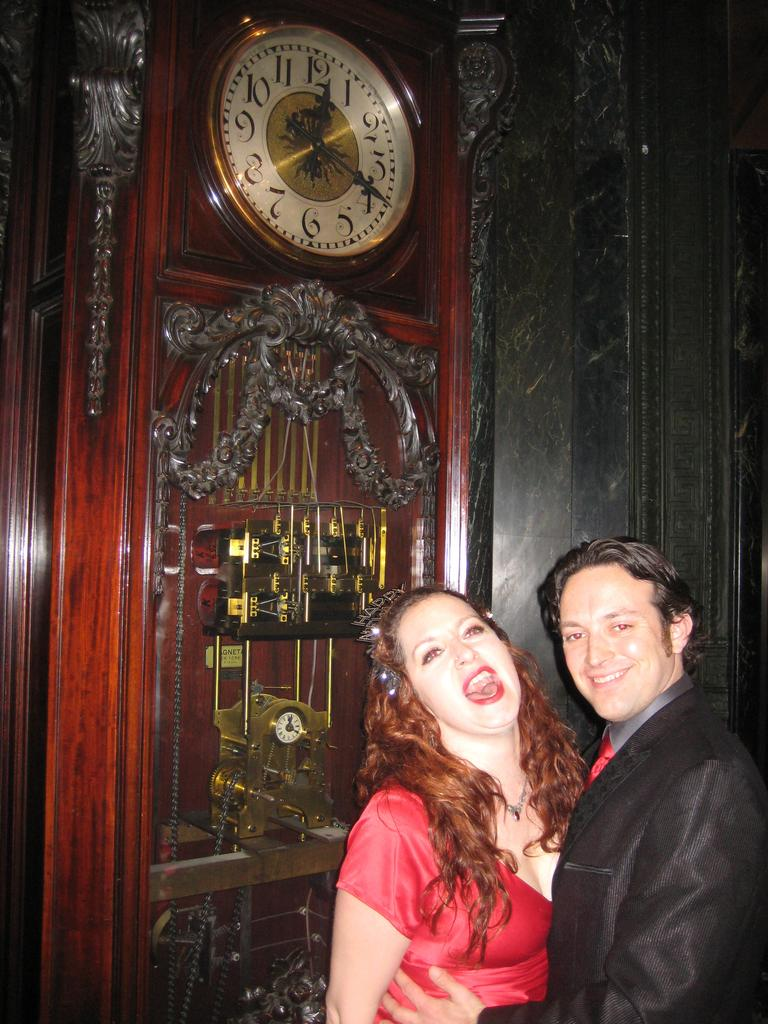Who is present in the image? There is a couple in the image. What is the couple doing in the image? The couple is smiling in the image. What object can be seen in the image that is used for measuring time? There is a clock in the image. What is the background of the image made of? There is a wall in the image. How many girls are present in the image? There are no girls present in the image; it features a couple. What type of crowd can be seen gathering around the couple in the image? There is no crowd present in the image; it only features the couple and the clock. 